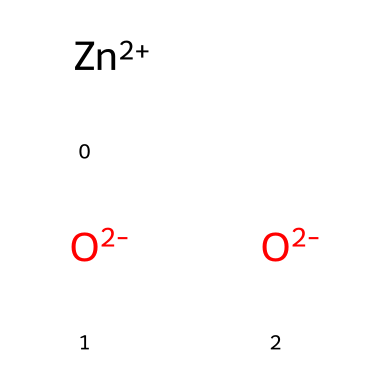what is the chemical formula of zinc oxide? The chemical formula can be derived from the SMILES representation, which shows one zinc atom (Zn) and two oxygen atoms (O). The compound is commonly known as zinc oxide, represented as ZnO.
Answer: ZnO how many total atoms are in zinc oxide? From the SMILES representation, we identify one zinc atom and two oxygen atoms. Adding these gives a total of three atoms in zinc oxide.
Answer: 3 what is the oxidation state of zinc in this compound? In the representation, zinc is shown with a +2 charge ([Zn+2]), indicating that the oxidation state of zinc in zinc oxide is +2.
Answer: +2 how many oxygen atoms are present in this compound? The SMILES shows two oxygen atoms ([O-2] and [O-2]), which are both present in the chemical structure of zinc oxide.
Answer: 2 is zinc oxide photoreactive? Zinc oxide is known to exhibit photoreactive properties when exposed to light due to its semiconductor characteristics. This behavior is mentioned in literature related to photoreactive chemicals.
Answer: Yes what type of bonding is present in zinc oxide? The bonding in zinc oxide includes ionic bonding between the positively charged zinc cation (Zn2+) and the negatively charged oxide anions (O2-), characteristic of ionic compounds like zinc oxide.
Answer: Ionic in what form is zinc oxide most commonly found in livestock mineral additives? Zinc oxide is primarily used in the form of a powder or fine particulate in livestock mineral additives, making it easy to incorporate into animal feed.
Answer: Powder 